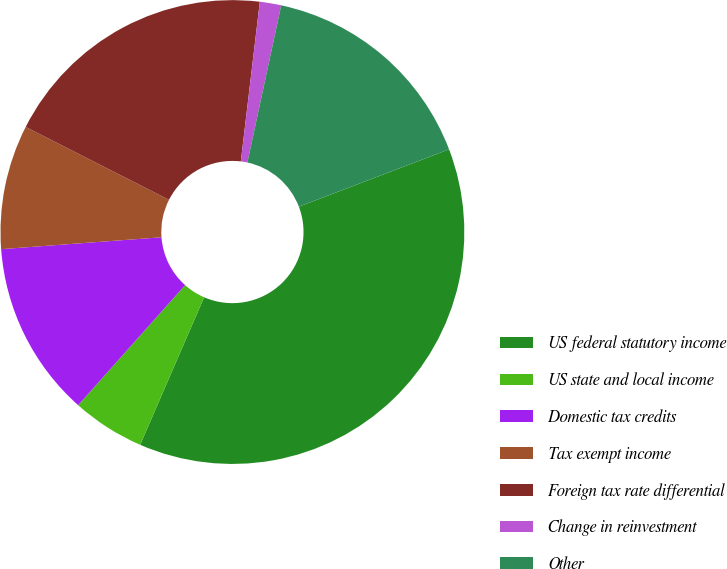Convert chart to OTSL. <chart><loc_0><loc_0><loc_500><loc_500><pie_chart><fcel>US federal statutory income<fcel>US state and local income<fcel>Domestic tax credits<fcel>Tax exempt income<fcel>Foreign tax rate differential<fcel>Change in reinvestment<fcel>Other<nl><fcel>37.31%<fcel>5.07%<fcel>12.24%<fcel>8.66%<fcel>19.4%<fcel>1.49%<fcel>15.82%<nl></chart> 